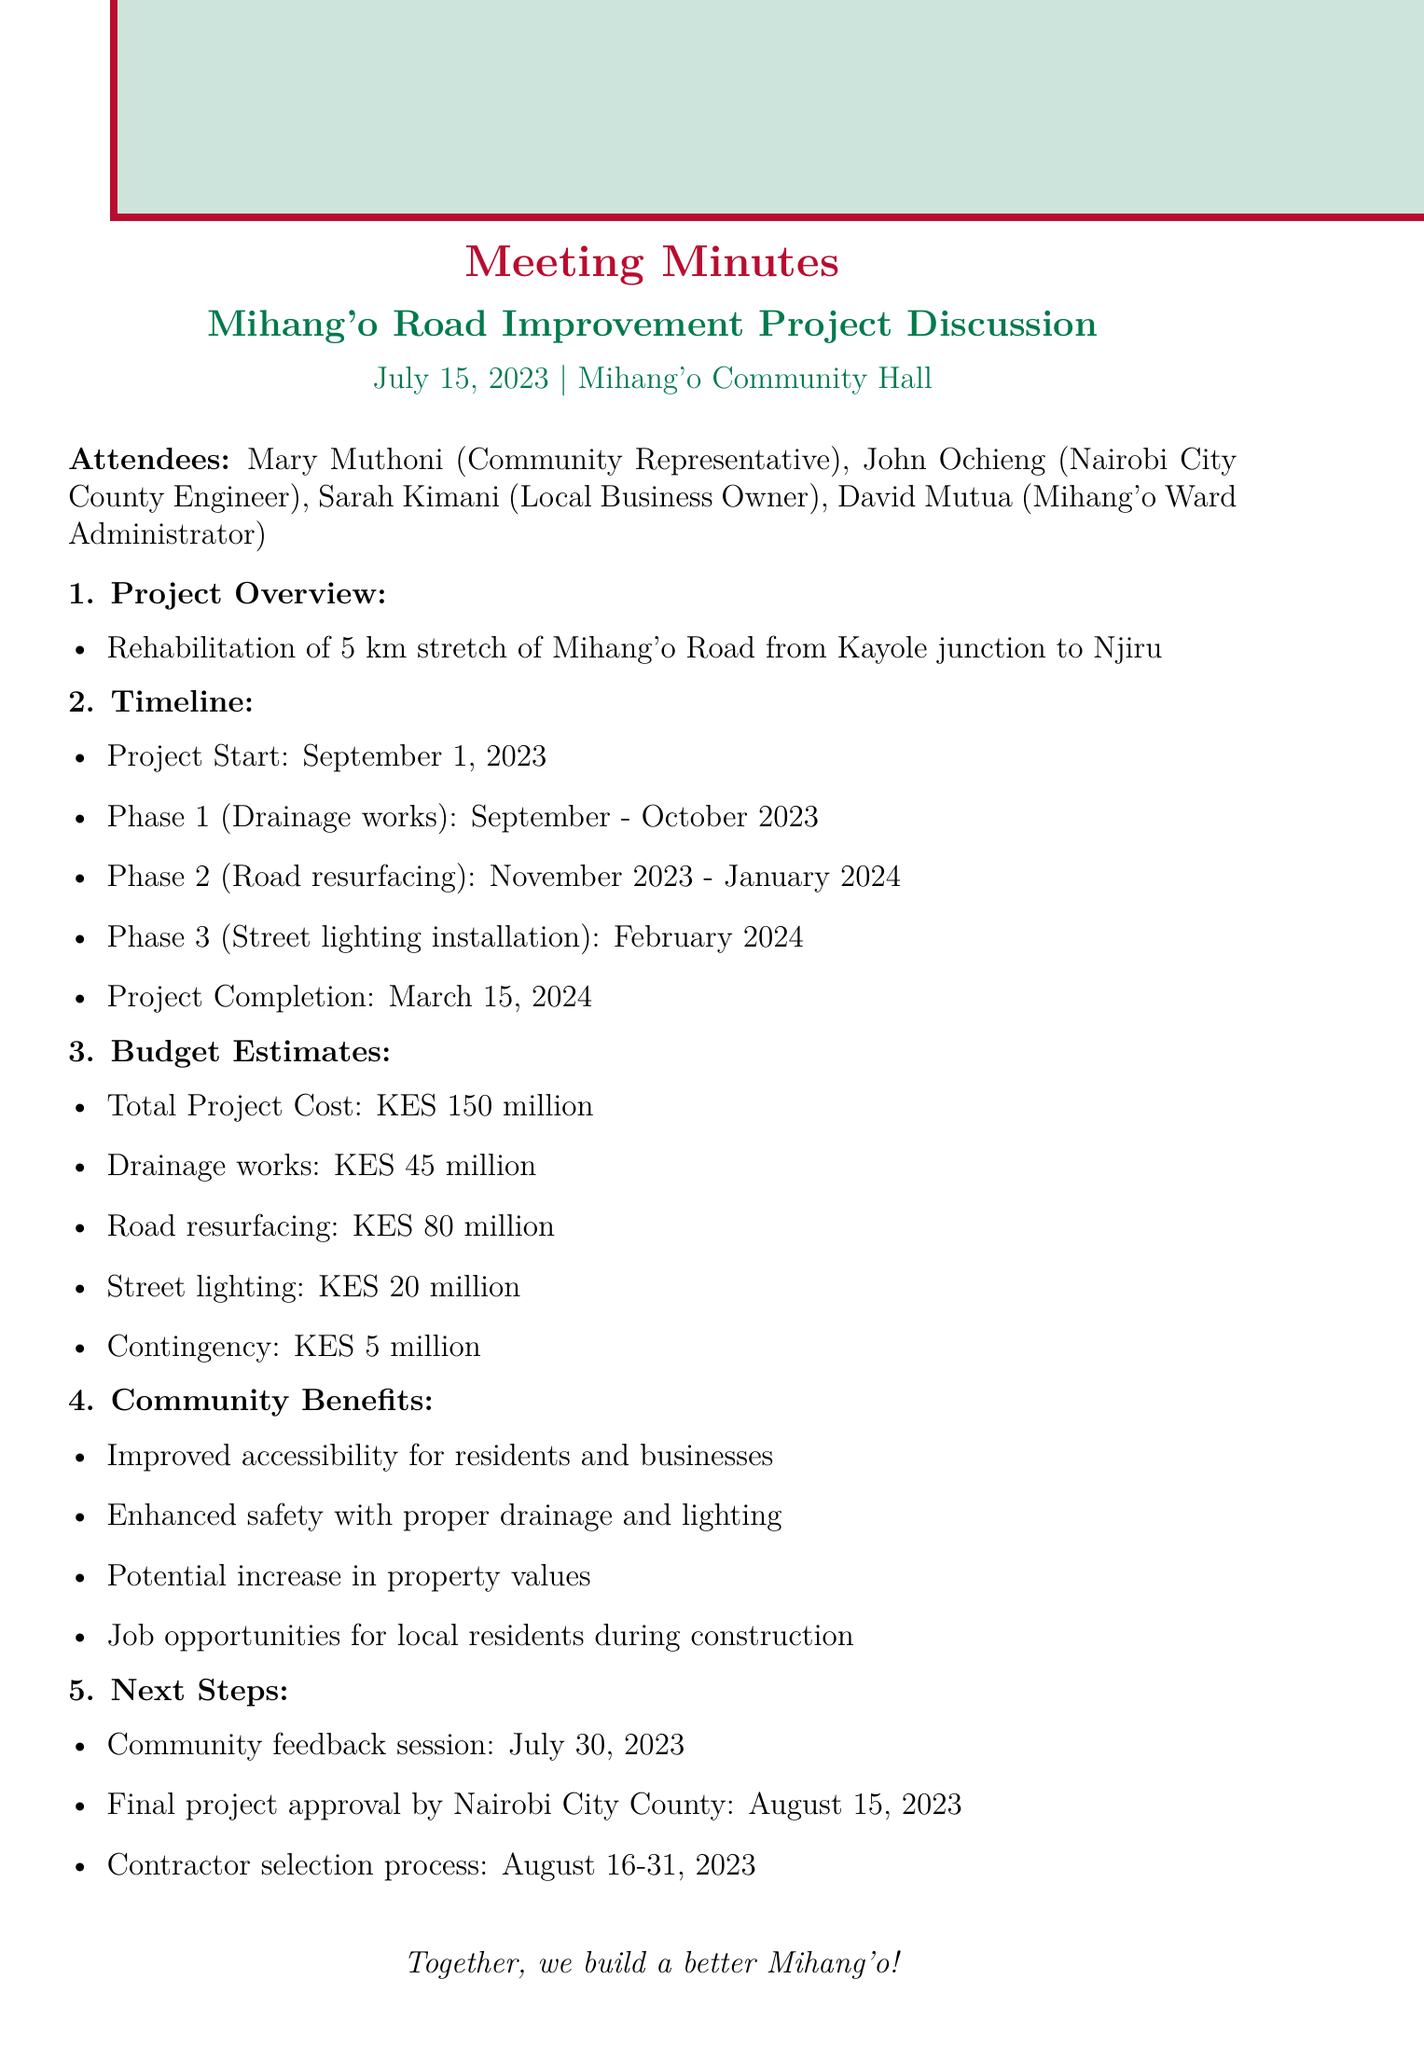What is the project start date? The project start date is explicitly mentioned in the timeline section of the document.
Answer: September 1, 2023 How long is the stretch of Mihang'o Road being rehabilitated? The length of the road stretch is provided in the project overview of the document.
Answer: 5 km What is the total project cost? The total project cost can be found in the budget estimates section of the document.
Answer: KES 150 million When is the community feedback session scheduled? The date for the community feedback session is listed under the next steps in the document.
Answer: July 30, 2023 What phase involves street lighting installation? The document outlines various project phases, detailing when street lighting installation will take place.
Answer: Phase 3 How much is allocated for drainage works? The allocation for drainage works is specified in the budget estimates section of the document.
Answer: KES 45 million What are the benefits mentioned for the community? The community benefits are directly stated in a bulleted list within the document.
Answer: Improved accessibility for residents and businesses Who is the Nairobi City County Engineer present at the meeting? The attendees of the meeting list the representatives present, including their roles.
Answer: John Ochieng What is the duration of the road resurfacing phase? The time frame for road resurfacing is detailed in the timeline section.
Answer: November 2023 - January 2024 